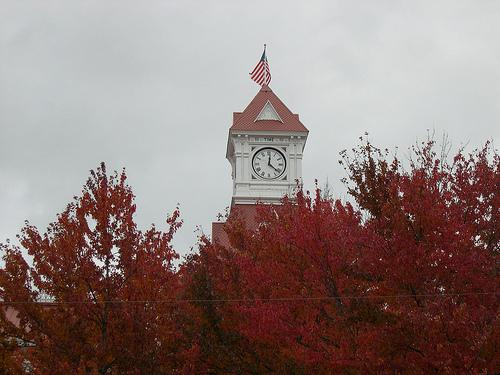Question: why is the sky gray?
Choices:
A. It is raining.
B. It is dusk.
C. It is cloudy.
D. It is dawn.
Answer with the letter. Answer: C Question: what country's flag is shown?
Choices:
A. Canada.
B. Mexico.
C. United states.
D. Argentina.
Answer with the letter. Answer: C Question: when does the clock say it is?
Choices:
A. 12:21.
B. 12:22.
C. 12:23.
D. 12:20.
Answer with the letter. Answer: D Question: what color are the trees?
Choices:
A. Red.
B. Yellow.
C. Orange.
D. Green.
Answer with the letter. Answer: A Question: who is pictured?
Choices:
A. No one.
B. The team.
C. The family.
D. The bride and groom.
Answer with the letter. Answer: A Question: where is the flag?
Choices:
A. Outside the building.
B. Hanging on the wall.
C. Above the clock.
D. Above the mantle.
Answer with the letter. Answer: C 